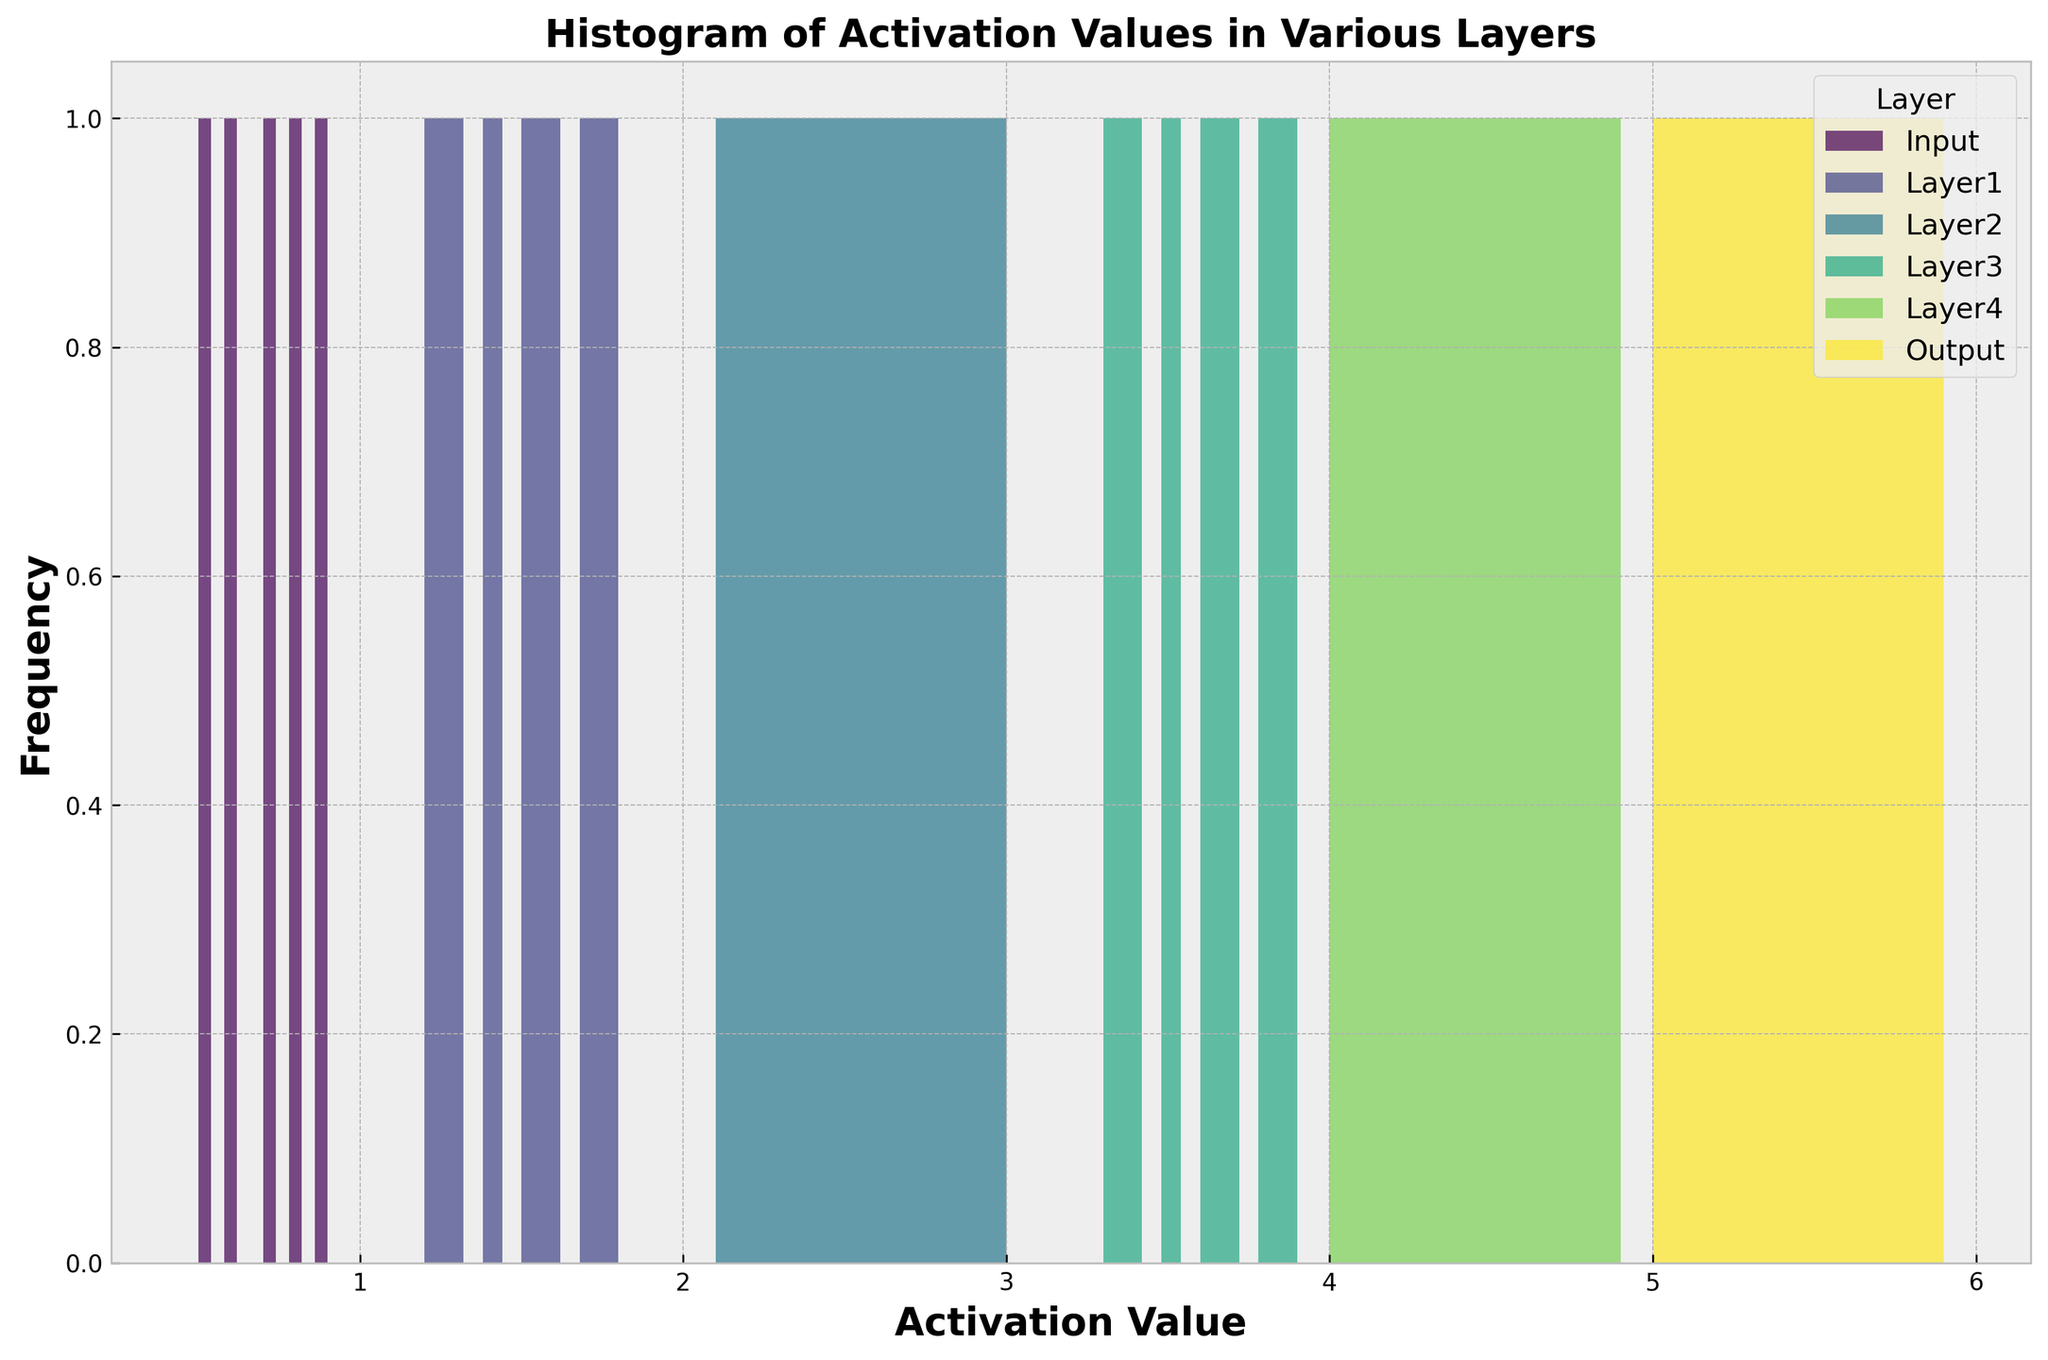Which layer has the highest peak in the histogram? To determine the layer with the highest peak, look at the histogram and identify the tallest bar. The tallest bar indicates the layer with the highest frequency of activation values in a particular range.
Answer: Output Which layer has the broadest range of activation values? The broadest range of activation values is found by observing which layer's histogram spans the largest interval on the x-axis.
Answer: Layer4 What is the difference between the maximum activation value in Layer3 and the minimum activation value in Layer4? In the histogram, Layer3's activation values range from 3.3 to about 3.9, and Layer4's activation values range from 4.0 to about 4.9. The minimum activation value in Layer4 is 4.0, and the maximum in Layer3 is about 3.9. The difference is 4.0 - 3.9.
Answer: 0.1 Which layer's histogram has the fewest bins with non-zero height? The histogram with the fewest bins that have a non-zero height means the histogram has fewer intervals with activation values. By looking at each histogram, you can count the non-zero bins.
Answer: Input Do any two layers have overlapping activation value ranges? Identifying overlapping ranges requires comparing the activation value spans for each layer. Determine if any intervals on the x-axis are shared by more than one layer. Layers with activation values starting where the previous layer's values end do not count as overlapping.
Answer: No Which layer shows the most uniform distribution of activation values? Uniform distribution means the bars are approximately of equal height. Examine each histogram to see which layer has bars of similar heights.
Answer: Layer3 Compare the frequency of activation values between Layer1 and Layer2. Which one has higher frequencies? To compare, look at the heights of the bars in the histograms of both Layer1 and Layer2. Identify which histogram consistently has taller bars, indicating higher frequencies of activation values.
Answer: Layer2 